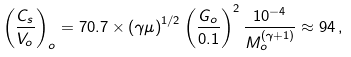Convert formula to latex. <formula><loc_0><loc_0><loc_500><loc_500>\left ( \frac { C _ { s } } { V _ { o } } \right ) _ { o } = 7 0 . 7 \times \left ( { \gamma \mu } \right ) ^ { 1 / 2 } \left ( \frac { G _ { o } } { 0 . 1 } \right ) ^ { 2 } \frac { 1 0 ^ { - 4 } } { M _ { o } ^ { ( \gamma + 1 ) } } \approx 9 4 \, ,</formula> 